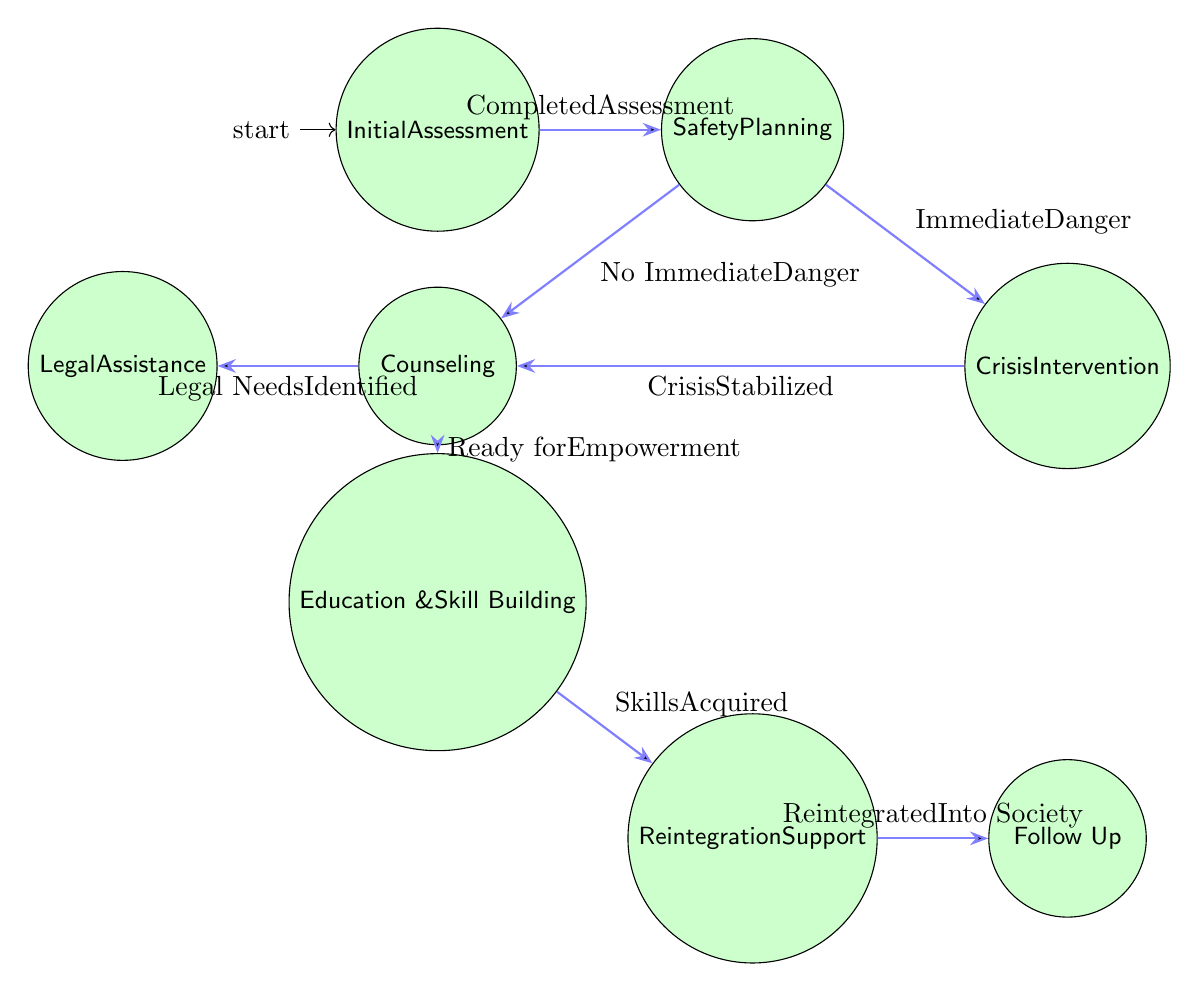What is the starting state of the rehabilitation program? The diagram indicates that the starting state is "Initial Assessment," which is the first node before any transitions occur.
Answer: Initial Assessment How many nodes are there in the diagram? By counting individual states within the diagram, we find there are a total of eight nodes representing different phases of the rehabilitation program.
Answer: 8 Which state follows "Crisis Intervention" if the crisis is stabilized? According to the diagram, if the crisis is stabilized, the flow moves from "Crisis Intervention" to "Counseling," representing ongoing therapeutic support thereafter.
Answer: Counseling What triggers the transition from "Safety Planning" to "Crisis Intervention"? The diagram specifies that the trigger moving the process from "Safety Planning" to "Crisis Intervention" is labeled as "Immediate Danger Identified."
Answer: Immediate Danger Identified How do survivors progress from "Counseling" to "Education and Skill Building"? The transition from "Counseling" to "Education and Skill Building" occurs when the trigger "Ready for Empowerment" is activated, indicating a readiness to acquire new skills.
Answer: Ready for Empowerment Which state is the last one in the program before follow-up occurs? The "Reintegration Support" state comes just before "Follow Up," creating the pathway for survivors to receive support in reintegrating into society before follow-up meetings are conducted.
Answer: Reintegration Support What is the relationship between "Counseling" and "Legal Assistance"? The arrow from "Counseling" to "Legal Assistance" illustrates that survivors proceed to legal assistance when their "Legal Needs Identified," emphasizing the importance of addressing legal issues during the counseling phase.
Answer: Legal Needs Identified After skills are acquired, which state do survivors enter? Following the acquisition of skills, represented by the transition triggered by "Skills Acquired," the next state survivors enter is "Reintegration Support," helping them utilize their new skills in society.
Answer: Reintegration Support 